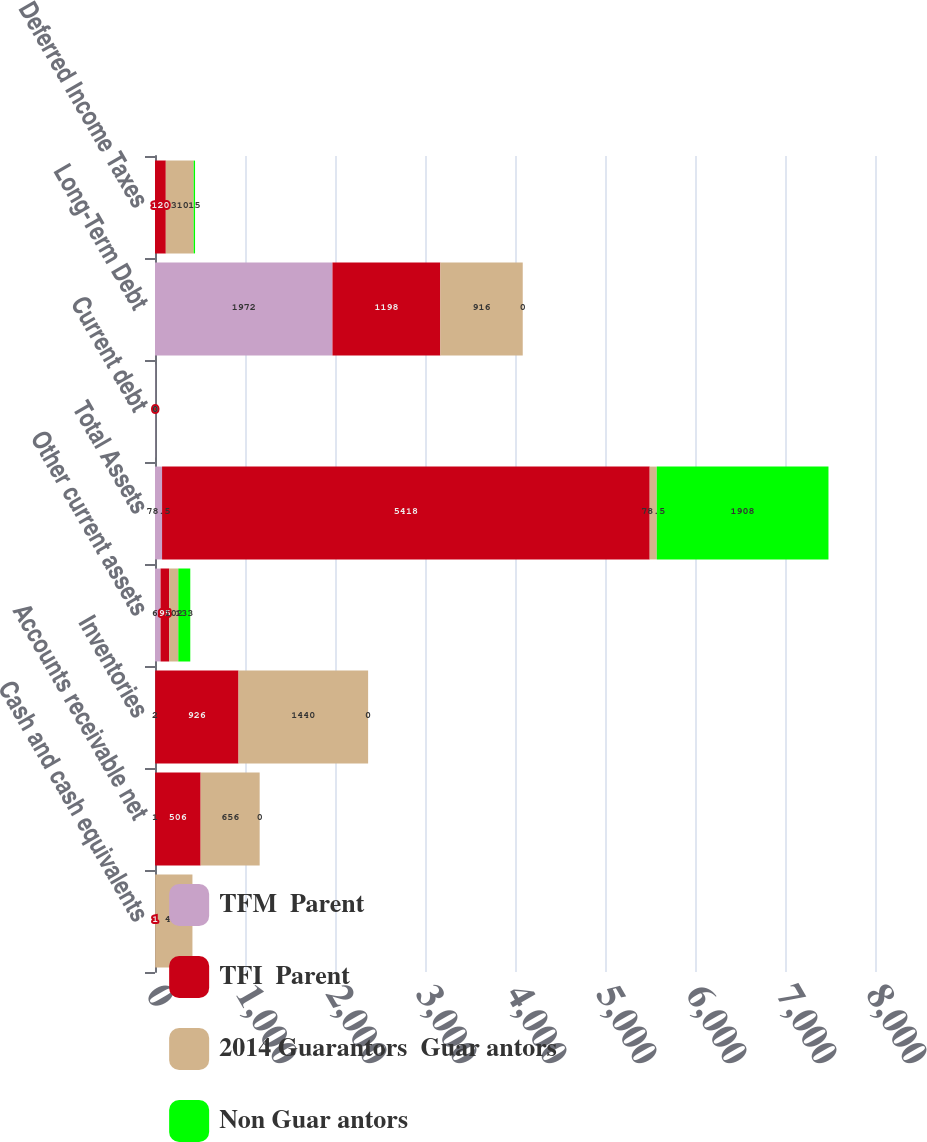<chart> <loc_0><loc_0><loc_500><loc_500><stacked_bar_chart><ecel><fcel>Cash and cash equivalents<fcel>Accounts receivable net<fcel>Inventories<fcel>Other current assets<fcel>Total Assets<fcel>Current debt<fcel>Long-Term Debt<fcel>Deferred Income Taxes<nl><fcel>TFM  Parent<fcel>1<fcel>1<fcel>2<fcel>62<fcel>78.5<fcel>2<fcel>1972<fcel>0<nl><fcel>TFI  Parent<fcel>1<fcel>506<fcel>926<fcel>95<fcel>5418<fcel>0<fcel>1198<fcel>120<nl><fcel>2014 Guarantors  Guar antors<fcel>414<fcel>656<fcel>1440<fcel>102<fcel>78.5<fcel>0<fcel>916<fcel>310<nl><fcel>Non Guar antors<fcel>0<fcel>0<fcel>0<fcel>133<fcel>1908<fcel>0<fcel>0<fcel>15<nl></chart> 